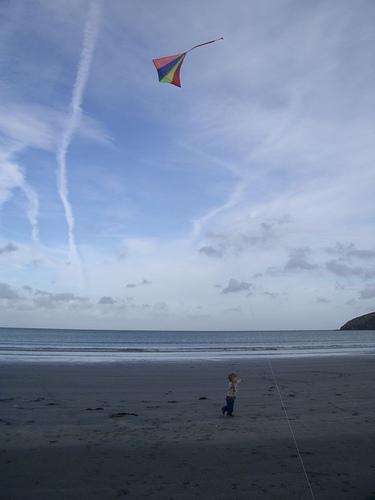How many people are there?
Give a very brief answer. 1. How many people are visible?
Give a very brief answer. 1. How many people walking on the beach?
Give a very brief answer. 1. 